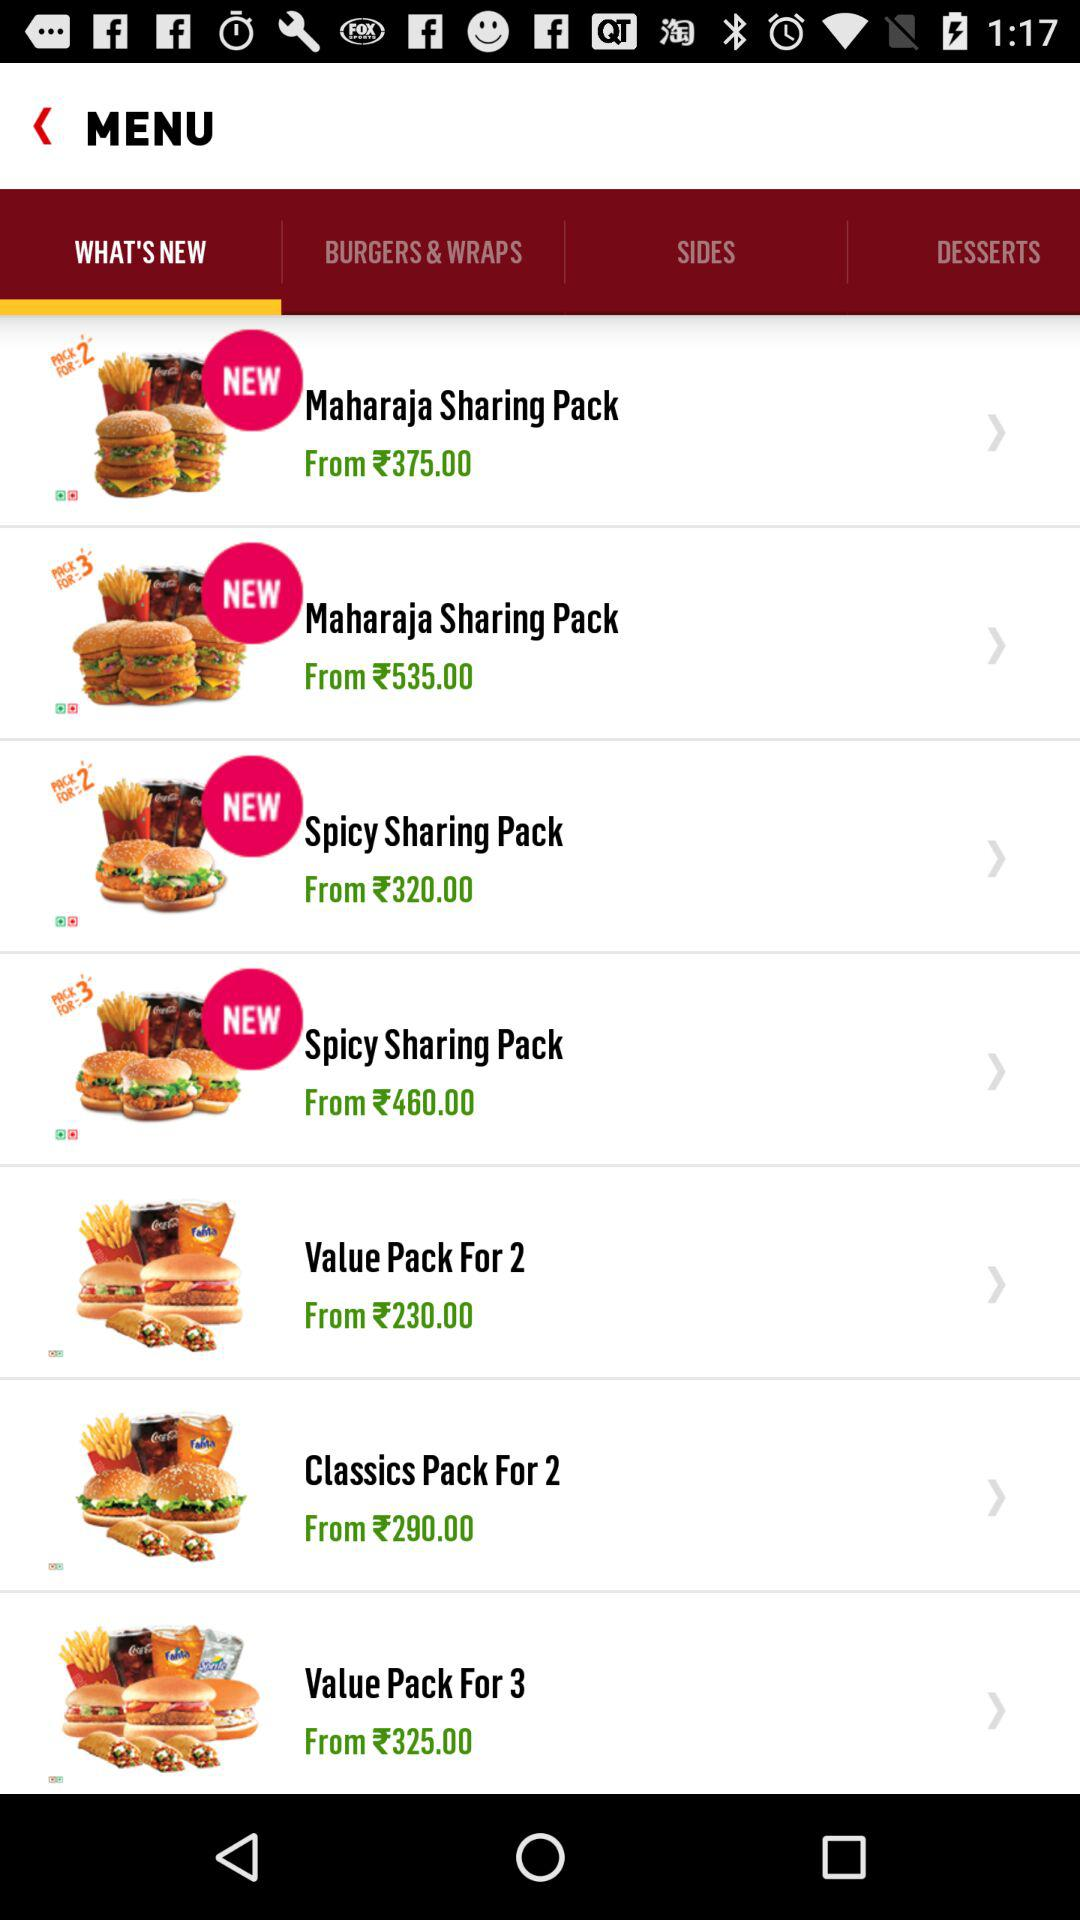What is the price of the "Value Pack For 3"? The price of the "Value Pack For 3" starts from 325 rupees. 